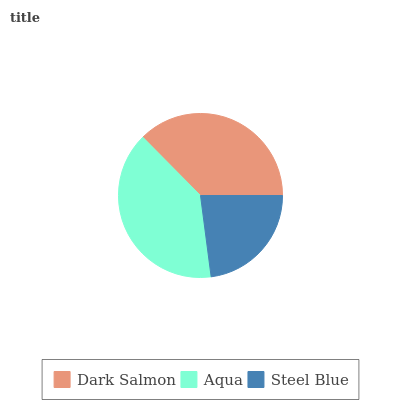Is Steel Blue the minimum?
Answer yes or no. Yes. Is Aqua the maximum?
Answer yes or no. Yes. Is Aqua the minimum?
Answer yes or no. No. Is Steel Blue the maximum?
Answer yes or no. No. Is Aqua greater than Steel Blue?
Answer yes or no. Yes. Is Steel Blue less than Aqua?
Answer yes or no. Yes. Is Steel Blue greater than Aqua?
Answer yes or no. No. Is Aqua less than Steel Blue?
Answer yes or no. No. Is Dark Salmon the high median?
Answer yes or no. Yes. Is Dark Salmon the low median?
Answer yes or no. Yes. Is Steel Blue the high median?
Answer yes or no. No. Is Aqua the low median?
Answer yes or no. No. 